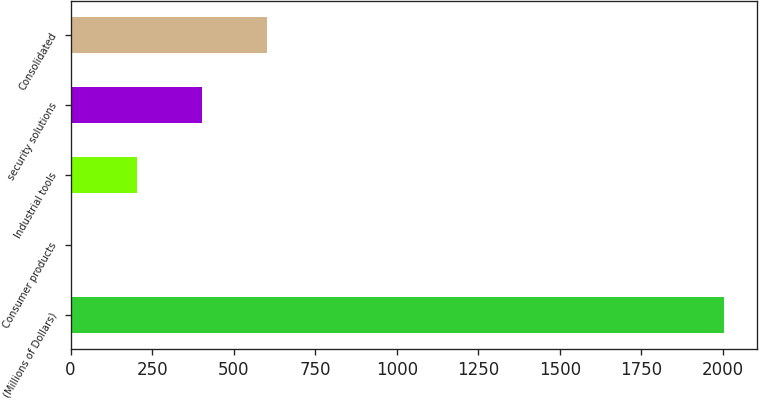Convert chart. <chart><loc_0><loc_0><loc_500><loc_500><bar_chart><fcel>(Millions of Dollars)<fcel>Consumer products<fcel>Industrial tools<fcel>security solutions<fcel>Consolidated<nl><fcel>2004<fcel>2.7<fcel>202.83<fcel>402.96<fcel>603.09<nl></chart> 